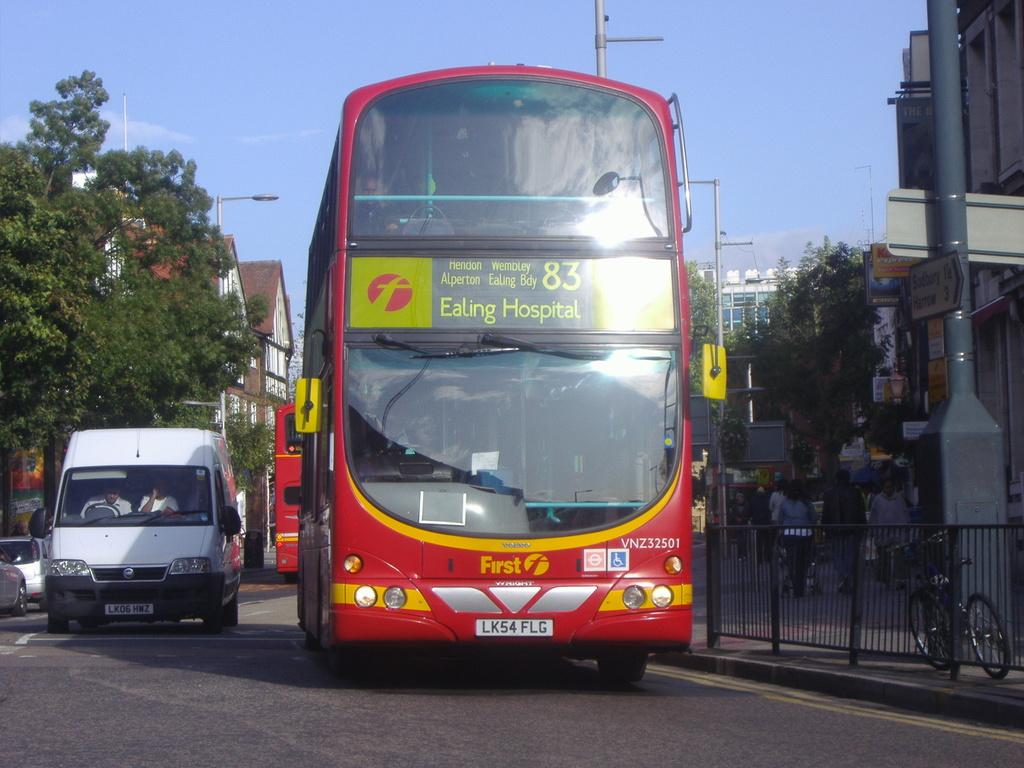Provide a one-sentence caption for the provided image. A double decker bus heading to Ealing Hospital rides down the street. 